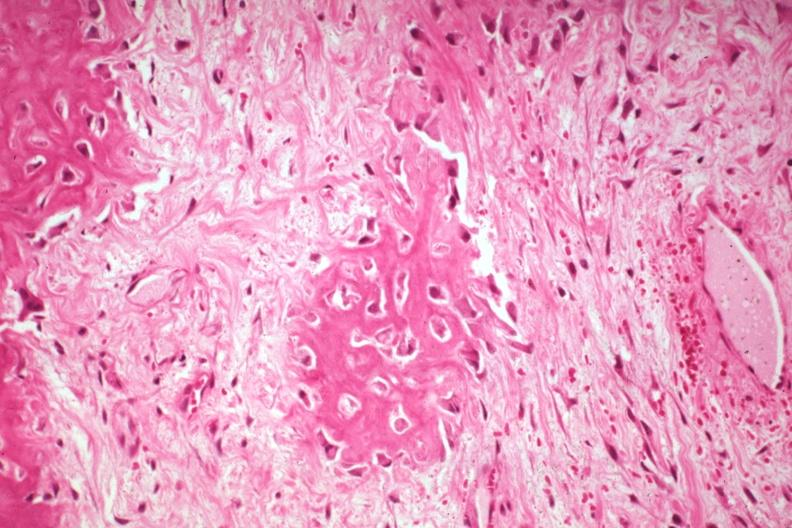what does this image show?
Answer the question using a single word or phrase. High fibrous callus and osteoid with osteoblasts from a non-union 